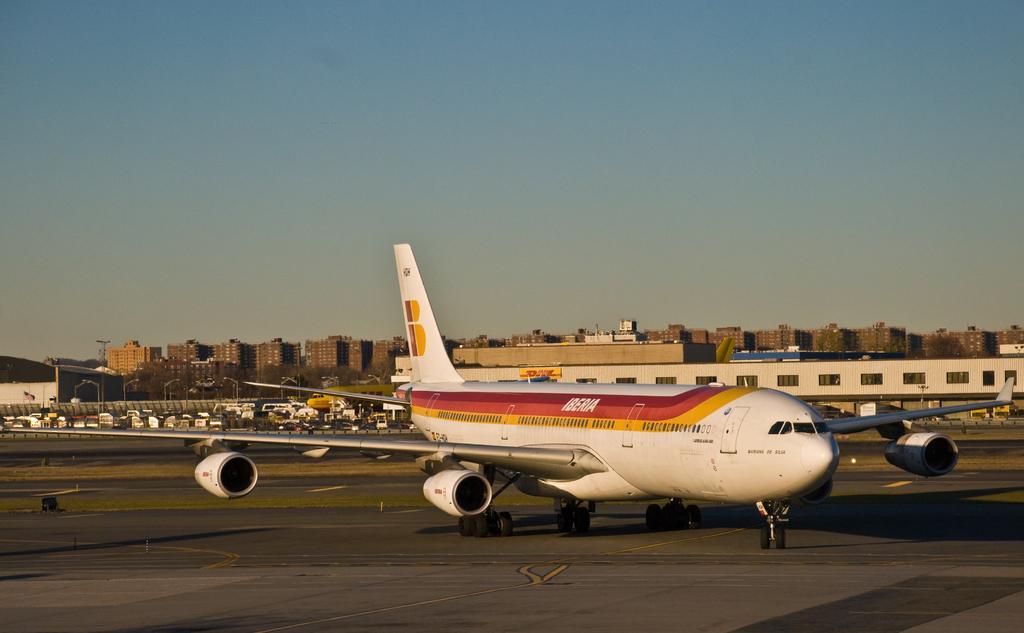In one or two sentences, can you explain what this image depicts? There is an aircraft in the foreground area of the image, there are vehicles, poles, buildings and the sky in the background. 